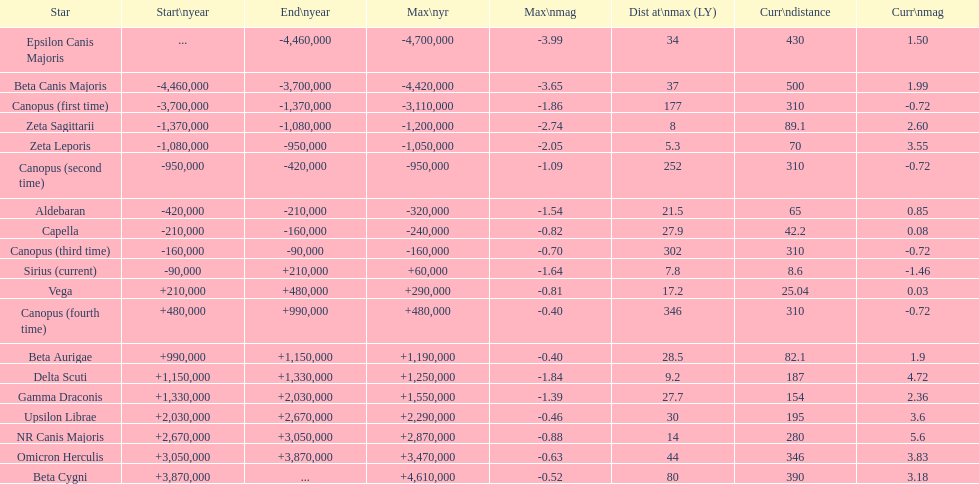Which star has the highest distance at maximum? Canopus (fourth time). 